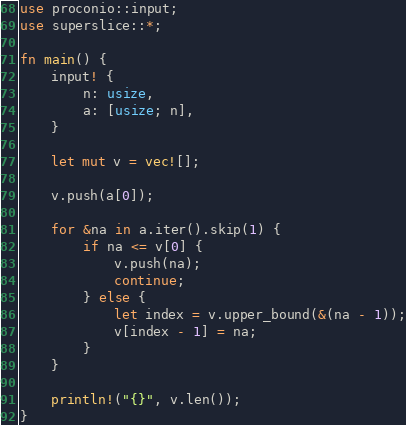Convert code to text. <code><loc_0><loc_0><loc_500><loc_500><_Rust_>use proconio::input;
use superslice::*;

fn main() {
    input! {
        n: usize,
        a: [usize; n],
    }

    let mut v = vec![];

    v.push(a[0]);

    for &na in a.iter().skip(1) {
        if na <= v[0] {
            v.push(na);
            continue;
        } else {
            let index = v.upper_bound(&(na - 1));
            v[index - 1] = na;
        }
    }

    println!("{}", v.len());
}
</code> 